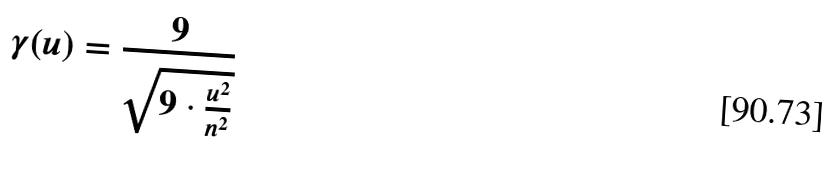Convert formula to latex. <formula><loc_0><loc_0><loc_500><loc_500>\gamma ( u ) = \frac { 9 } { \sqrt { 9 \cdot \frac { u ^ { 2 } } { n ^ { 2 } } } }</formula> 